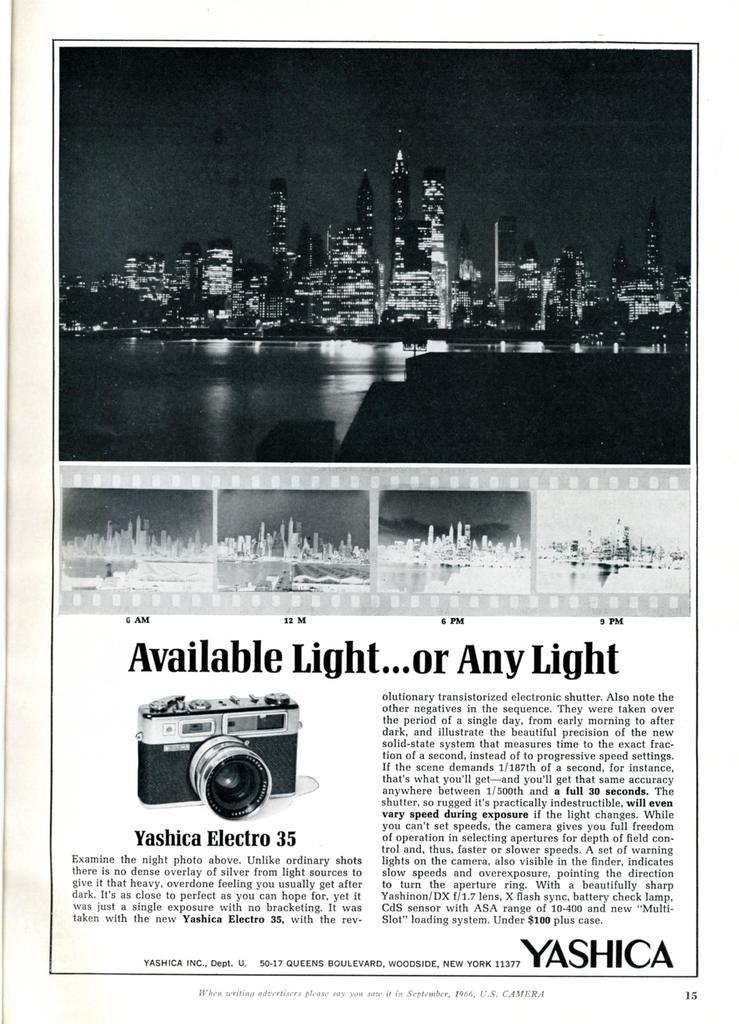<image>
Provide a brief description of the given image. Page showing a skyline on top and the word "YASHICA" on the bottom. 